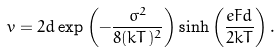Convert formula to latex. <formula><loc_0><loc_0><loc_500><loc_500>v = 2 d \exp \left ( - \frac { \sigma ^ { 2 } } { 8 ( k T ) ^ { 2 } } \right ) \sinh \left ( \frac { e F d } { 2 k T } \right ) .</formula> 